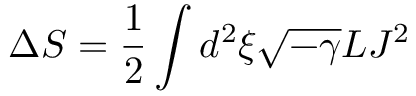Convert formula to latex. <formula><loc_0><loc_0><loc_500><loc_500>\Delta S = \frac { 1 } { 2 } \int d ^ { 2 } \xi \sqrt { - \gamma } L J ^ { 2 }</formula> 